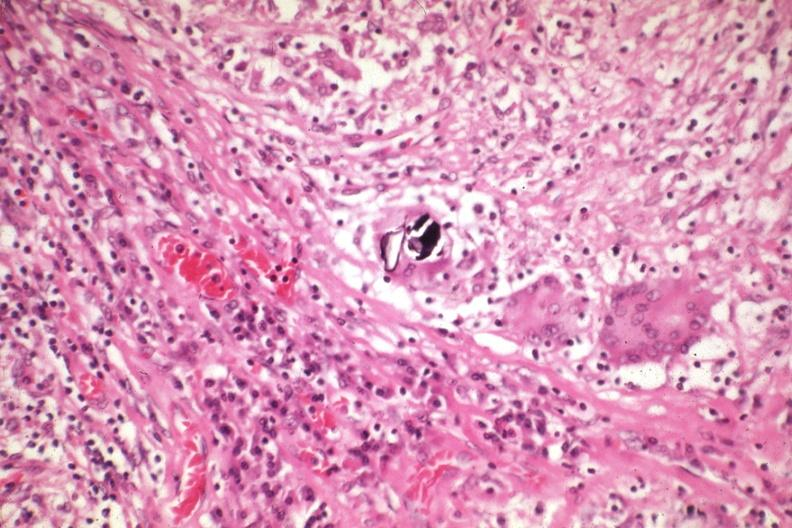s sarcoidosis present?
Answer the question using a single word or phrase. Yes 